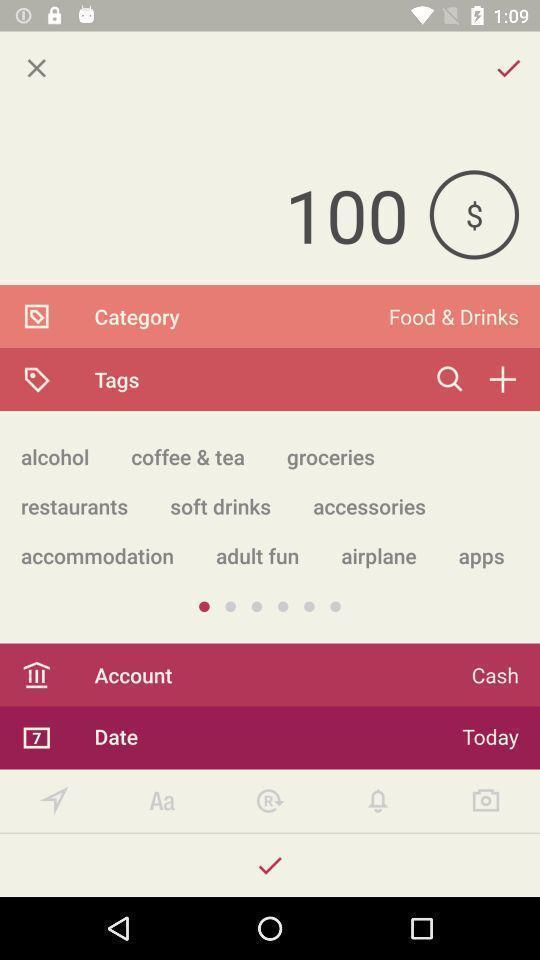Tell me about the visual elements in this screen capture. Screen shows an all-in-one tracking app. 